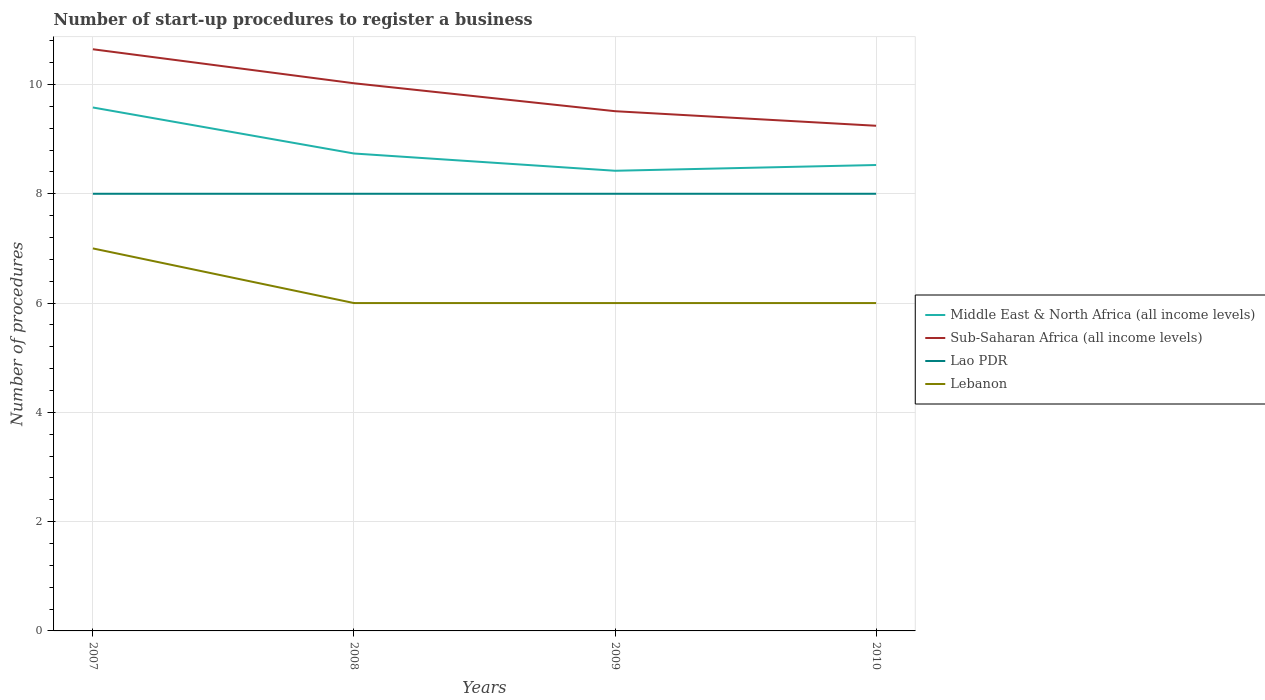How many different coloured lines are there?
Your answer should be compact. 4. Across all years, what is the maximum number of procedures required to register a business in Middle East & North Africa (all income levels)?
Your response must be concise. 8.42. What is the total number of procedures required to register a business in Middle East & North Africa (all income levels) in the graph?
Provide a short and direct response. 1.16. What is the difference between the highest and the second highest number of procedures required to register a business in Middle East & North Africa (all income levels)?
Keep it short and to the point. 1.16. What is the difference between two consecutive major ticks on the Y-axis?
Offer a terse response. 2. Does the graph contain grids?
Make the answer very short. Yes. Where does the legend appear in the graph?
Keep it short and to the point. Center right. What is the title of the graph?
Offer a very short reply. Number of start-up procedures to register a business. Does "Spain" appear as one of the legend labels in the graph?
Provide a succinct answer. No. What is the label or title of the Y-axis?
Offer a terse response. Number of procedures. What is the Number of procedures in Middle East & North Africa (all income levels) in 2007?
Provide a short and direct response. 9.58. What is the Number of procedures of Sub-Saharan Africa (all income levels) in 2007?
Your answer should be very brief. 10.64. What is the Number of procedures in Lebanon in 2007?
Make the answer very short. 7. What is the Number of procedures of Middle East & North Africa (all income levels) in 2008?
Provide a succinct answer. 8.74. What is the Number of procedures in Sub-Saharan Africa (all income levels) in 2008?
Make the answer very short. 10.02. What is the Number of procedures of Lao PDR in 2008?
Offer a terse response. 8. What is the Number of procedures in Lebanon in 2008?
Keep it short and to the point. 6. What is the Number of procedures of Middle East & North Africa (all income levels) in 2009?
Give a very brief answer. 8.42. What is the Number of procedures of Sub-Saharan Africa (all income levels) in 2009?
Provide a short and direct response. 9.51. What is the Number of procedures of Lao PDR in 2009?
Keep it short and to the point. 8. What is the Number of procedures in Middle East & North Africa (all income levels) in 2010?
Your answer should be compact. 8.53. What is the Number of procedures in Sub-Saharan Africa (all income levels) in 2010?
Make the answer very short. 9.24. Across all years, what is the maximum Number of procedures in Middle East & North Africa (all income levels)?
Your response must be concise. 9.58. Across all years, what is the maximum Number of procedures in Sub-Saharan Africa (all income levels)?
Provide a short and direct response. 10.64. Across all years, what is the maximum Number of procedures of Lao PDR?
Your answer should be very brief. 8. Across all years, what is the maximum Number of procedures in Lebanon?
Your answer should be very brief. 7. Across all years, what is the minimum Number of procedures of Middle East & North Africa (all income levels)?
Ensure brevity in your answer.  8.42. Across all years, what is the minimum Number of procedures in Sub-Saharan Africa (all income levels)?
Provide a short and direct response. 9.24. Across all years, what is the minimum Number of procedures of Lao PDR?
Provide a succinct answer. 8. What is the total Number of procedures in Middle East & North Africa (all income levels) in the graph?
Ensure brevity in your answer.  35.26. What is the total Number of procedures in Sub-Saharan Africa (all income levels) in the graph?
Provide a short and direct response. 39.42. What is the total Number of procedures of Lao PDR in the graph?
Provide a short and direct response. 32. What is the difference between the Number of procedures in Middle East & North Africa (all income levels) in 2007 and that in 2008?
Keep it short and to the point. 0.84. What is the difference between the Number of procedures of Sub-Saharan Africa (all income levels) in 2007 and that in 2008?
Give a very brief answer. 0.62. What is the difference between the Number of procedures of Lao PDR in 2007 and that in 2008?
Provide a short and direct response. 0. What is the difference between the Number of procedures of Middle East & North Africa (all income levels) in 2007 and that in 2009?
Your response must be concise. 1.16. What is the difference between the Number of procedures in Sub-Saharan Africa (all income levels) in 2007 and that in 2009?
Offer a very short reply. 1.13. What is the difference between the Number of procedures in Lao PDR in 2007 and that in 2009?
Provide a succinct answer. 0. What is the difference between the Number of procedures of Middle East & North Africa (all income levels) in 2007 and that in 2010?
Your answer should be very brief. 1.05. What is the difference between the Number of procedures in Lao PDR in 2007 and that in 2010?
Ensure brevity in your answer.  0. What is the difference between the Number of procedures in Middle East & North Africa (all income levels) in 2008 and that in 2009?
Provide a succinct answer. 0.32. What is the difference between the Number of procedures of Sub-Saharan Africa (all income levels) in 2008 and that in 2009?
Your response must be concise. 0.51. What is the difference between the Number of procedures in Middle East & North Africa (all income levels) in 2008 and that in 2010?
Offer a terse response. 0.21. What is the difference between the Number of procedures in Sub-Saharan Africa (all income levels) in 2008 and that in 2010?
Your response must be concise. 0.78. What is the difference between the Number of procedures in Lebanon in 2008 and that in 2010?
Ensure brevity in your answer.  0. What is the difference between the Number of procedures in Middle East & North Africa (all income levels) in 2009 and that in 2010?
Your answer should be compact. -0.11. What is the difference between the Number of procedures in Sub-Saharan Africa (all income levels) in 2009 and that in 2010?
Your answer should be very brief. 0.27. What is the difference between the Number of procedures of Lebanon in 2009 and that in 2010?
Provide a succinct answer. 0. What is the difference between the Number of procedures of Middle East & North Africa (all income levels) in 2007 and the Number of procedures of Sub-Saharan Africa (all income levels) in 2008?
Your answer should be very brief. -0.44. What is the difference between the Number of procedures of Middle East & North Africa (all income levels) in 2007 and the Number of procedures of Lao PDR in 2008?
Your answer should be compact. 1.58. What is the difference between the Number of procedures of Middle East & North Africa (all income levels) in 2007 and the Number of procedures of Lebanon in 2008?
Your response must be concise. 3.58. What is the difference between the Number of procedures in Sub-Saharan Africa (all income levels) in 2007 and the Number of procedures in Lao PDR in 2008?
Your answer should be compact. 2.64. What is the difference between the Number of procedures in Sub-Saharan Africa (all income levels) in 2007 and the Number of procedures in Lebanon in 2008?
Provide a succinct answer. 4.64. What is the difference between the Number of procedures in Middle East & North Africa (all income levels) in 2007 and the Number of procedures in Sub-Saharan Africa (all income levels) in 2009?
Provide a short and direct response. 0.07. What is the difference between the Number of procedures of Middle East & North Africa (all income levels) in 2007 and the Number of procedures of Lao PDR in 2009?
Give a very brief answer. 1.58. What is the difference between the Number of procedures in Middle East & North Africa (all income levels) in 2007 and the Number of procedures in Lebanon in 2009?
Give a very brief answer. 3.58. What is the difference between the Number of procedures of Sub-Saharan Africa (all income levels) in 2007 and the Number of procedures of Lao PDR in 2009?
Your answer should be very brief. 2.64. What is the difference between the Number of procedures of Sub-Saharan Africa (all income levels) in 2007 and the Number of procedures of Lebanon in 2009?
Your answer should be very brief. 4.64. What is the difference between the Number of procedures of Lao PDR in 2007 and the Number of procedures of Lebanon in 2009?
Keep it short and to the point. 2. What is the difference between the Number of procedures in Middle East & North Africa (all income levels) in 2007 and the Number of procedures in Sub-Saharan Africa (all income levels) in 2010?
Ensure brevity in your answer.  0.33. What is the difference between the Number of procedures of Middle East & North Africa (all income levels) in 2007 and the Number of procedures of Lao PDR in 2010?
Give a very brief answer. 1.58. What is the difference between the Number of procedures in Middle East & North Africa (all income levels) in 2007 and the Number of procedures in Lebanon in 2010?
Your response must be concise. 3.58. What is the difference between the Number of procedures in Sub-Saharan Africa (all income levels) in 2007 and the Number of procedures in Lao PDR in 2010?
Your answer should be compact. 2.64. What is the difference between the Number of procedures in Sub-Saharan Africa (all income levels) in 2007 and the Number of procedures in Lebanon in 2010?
Offer a very short reply. 4.64. What is the difference between the Number of procedures in Middle East & North Africa (all income levels) in 2008 and the Number of procedures in Sub-Saharan Africa (all income levels) in 2009?
Make the answer very short. -0.77. What is the difference between the Number of procedures of Middle East & North Africa (all income levels) in 2008 and the Number of procedures of Lao PDR in 2009?
Provide a succinct answer. 0.74. What is the difference between the Number of procedures in Middle East & North Africa (all income levels) in 2008 and the Number of procedures in Lebanon in 2009?
Provide a succinct answer. 2.74. What is the difference between the Number of procedures in Sub-Saharan Africa (all income levels) in 2008 and the Number of procedures in Lao PDR in 2009?
Keep it short and to the point. 2.02. What is the difference between the Number of procedures of Sub-Saharan Africa (all income levels) in 2008 and the Number of procedures of Lebanon in 2009?
Your answer should be compact. 4.02. What is the difference between the Number of procedures of Lao PDR in 2008 and the Number of procedures of Lebanon in 2009?
Provide a short and direct response. 2. What is the difference between the Number of procedures in Middle East & North Africa (all income levels) in 2008 and the Number of procedures in Sub-Saharan Africa (all income levels) in 2010?
Provide a short and direct response. -0.51. What is the difference between the Number of procedures in Middle East & North Africa (all income levels) in 2008 and the Number of procedures in Lao PDR in 2010?
Give a very brief answer. 0.74. What is the difference between the Number of procedures in Middle East & North Africa (all income levels) in 2008 and the Number of procedures in Lebanon in 2010?
Your response must be concise. 2.74. What is the difference between the Number of procedures in Sub-Saharan Africa (all income levels) in 2008 and the Number of procedures in Lao PDR in 2010?
Your response must be concise. 2.02. What is the difference between the Number of procedures of Sub-Saharan Africa (all income levels) in 2008 and the Number of procedures of Lebanon in 2010?
Provide a succinct answer. 4.02. What is the difference between the Number of procedures in Lao PDR in 2008 and the Number of procedures in Lebanon in 2010?
Keep it short and to the point. 2. What is the difference between the Number of procedures of Middle East & North Africa (all income levels) in 2009 and the Number of procedures of Sub-Saharan Africa (all income levels) in 2010?
Provide a short and direct response. -0.82. What is the difference between the Number of procedures in Middle East & North Africa (all income levels) in 2009 and the Number of procedures in Lao PDR in 2010?
Give a very brief answer. 0.42. What is the difference between the Number of procedures in Middle East & North Africa (all income levels) in 2009 and the Number of procedures in Lebanon in 2010?
Provide a succinct answer. 2.42. What is the difference between the Number of procedures in Sub-Saharan Africa (all income levels) in 2009 and the Number of procedures in Lao PDR in 2010?
Provide a short and direct response. 1.51. What is the difference between the Number of procedures of Sub-Saharan Africa (all income levels) in 2009 and the Number of procedures of Lebanon in 2010?
Your answer should be compact. 3.51. What is the difference between the Number of procedures of Lao PDR in 2009 and the Number of procedures of Lebanon in 2010?
Provide a succinct answer. 2. What is the average Number of procedures in Middle East & North Africa (all income levels) per year?
Your answer should be very brief. 8.82. What is the average Number of procedures in Sub-Saharan Africa (all income levels) per year?
Provide a succinct answer. 9.86. What is the average Number of procedures in Lebanon per year?
Offer a terse response. 6.25. In the year 2007, what is the difference between the Number of procedures of Middle East & North Africa (all income levels) and Number of procedures of Sub-Saharan Africa (all income levels)?
Your response must be concise. -1.07. In the year 2007, what is the difference between the Number of procedures of Middle East & North Africa (all income levels) and Number of procedures of Lao PDR?
Your response must be concise. 1.58. In the year 2007, what is the difference between the Number of procedures in Middle East & North Africa (all income levels) and Number of procedures in Lebanon?
Your answer should be compact. 2.58. In the year 2007, what is the difference between the Number of procedures in Sub-Saharan Africa (all income levels) and Number of procedures in Lao PDR?
Your answer should be compact. 2.64. In the year 2007, what is the difference between the Number of procedures in Sub-Saharan Africa (all income levels) and Number of procedures in Lebanon?
Provide a short and direct response. 3.64. In the year 2007, what is the difference between the Number of procedures in Lao PDR and Number of procedures in Lebanon?
Your response must be concise. 1. In the year 2008, what is the difference between the Number of procedures in Middle East & North Africa (all income levels) and Number of procedures in Sub-Saharan Africa (all income levels)?
Give a very brief answer. -1.29. In the year 2008, what is the difference between the Number of procedures in Middle East & North Africa (all income levels) and Number of procedures in Lao PDR?
Provide a succinct answer. 0.74. In the year 2008, what is the difference between the Number of procedures in Middle East & North Africa (all income levels) and Number of procedures in Lebanon?
Keep it short and to the point. 2.74. In the year 2008, what is the difference between the Number of procedures of Sub-Saharan Africa (all income levels) and Number of procedures of Lao PDR?
Provide a short and direct response. 2.02. In the year 2008, what is the difference between the Number of procedures of Sub-Saharan Africa (all income levels) and Number of procedures of Lebanon?
Provide a short and direct response. 4.02. In the year 2009, what is the difference between the Number of procedures of Middle East & North Africa (all income levels) and Number of procedures of Sub-Saharan Africa (all income levels)?
Keep it short and to the point. -1.09. In the year 2009, what is the difference between the Number of procedures of Middle East & North Africa (all income levels) and Number of procedures of Lao PDR?
Offer a terse response. 0.42. In the year 2009, what is the difference between the Number of procedures in Middle East & North Africa (all income levels) and Number of procedures in Lebanon?
Ensure brevity in your answer.  2.42. In the year 2009, what is the difference between the Number of procedures in Sub-Saharan Africa (all income levels) and Number of procedures in Lao PDR?
Offer a very short reply. 1.51. In the year 2009, what is the difference between the Number of procedures in Sub-Saharan Africa (all income levels) and Number of procedures in Lebanon?
Give a very brief answer. 3.51. In the year 2009, what is the difference between the Number of procedures of Lao PDR and Number of procedures of Lebanon?
Give a very brief answer. 2. In the year 2010, what is the difference between the Number of procedures in Middle East & North Africa (all income levels) and Number of procedures in Sub-Saharan Africa (all income levels)?
Make the answer very short. -0.72. In the year 2010, what is the difference between the Number of procedures of Middle East & North Africa (all income levels) and Number of procedures of Lao PDR?
Your answer should be very brief. 0.53. In the year 2010, what is the difference between the Number of procedures of Middle East & North Africa (all income levels) and Number of procedures of Lebanon?
Your answer should be very brief. 2.53. In the year 2010, what is the difference between the Number of procedures of Sub-Saharan Africa (all income levels) and Number of procedures of Lao PDR?
Your answer should be compact. 1.24. In the year 2010, what is the difference between the Number of procedures in Sub-Saharan Africa (all income levels) and Number of procedures in Lebanon?
Your response must be concise. 3.24. What is the ratio of the Number of procedures of Middle East & North Africa (all income levels) in 2007 to that in 2008?
Give a very brief answer. 1.1. What is the ratio of the Number of procedures in Sub-Saharan Africa (all income levels) in 2007 to that in 2008?
Make the answer very short. 1.06. What is the ratio of the Number of procedures in Lao PDR in 2007 to that in 2008?
Keep it short and to the point. 1. What is the ratio of the Number of procedures in Lebanon in 2007 to that in 2008?
Provide a short and direct response. 1.17. What is the ratio of the Number of procedures of Middle East & North Africa (all income levels) in 2007 to that in 2009?
Offer a very short reply. 1.14. What is the ratio of the Number of procedures in Sub-Saharan Africa (all income levels) in 2007 to that in 2009?
Your answer should be very brief. 1.12. What is the ratio of the Number of procedures of Lebanon in 2007 to that in 2009?
Ensure brevity in your answer.  1.17. What is the ratio of the Number of procedures of Middle East & North Africa (all income levels) in 2007 to that in 2010?
Your answer should be very brief. 1.12. What is the ratio of the Number of procedures of Sub-Saharan Africa (all income levels) in 2007 to that in 2010?
Give a very brief answer. 1.15. What is the ratio of the Number of procedures in Lao PDR in 2007 to that in 2010?
Your answer should be very brief. 1. What is the ratio of the Number of procedures of Middle East & North Africa (all income levels) in 2008 to that in 2009?
Give a very brief answer. 1.04. What is the ratio of the Number of procedures in Sub-Saharan Africa (all income levels) in 2008 to that in 2009?
Make the answer very short. 1.05. What is the ratio of the Number of procedures in Lebanon in 2008 to that in 2009?
Offer a very short reply. 1. What is the ratio of the Number of procedures in Middle East & North Africa (all income levels) in 2008 to that in 2010?
Offer a terse response. 1.02. What is the ratio of the Number of procedures in Sub-Saharan Africa (all income levels) in 2008 to that in 2010?
Your answer should be compact. 1.08. What is the ratio of the Number of procedures of Lao PDR in 2008 to that in 2010?
Offer a very short reply. 1. What is the ratio of the Number of procedures of Lebanon in 2008 to that in 2010?
Ensure brevity in your answer.  1. What is the ratio of the Number of procedures of Sub-Saharan Africa (all income levels) in 2009 to that in 2010?
Provide a short and direct response. 1.03. What is the ratio of the Number of procedures in Lao PDR in 2009 to that in 2010?
Ensure brevity in your answer.  1. What is the ratio of the Number of procedures in Lebanon in 2009 to that in 2010?
Offer a very short reply. 1. What is the difference between the highest and the second highest Number of procedures in Middle East & North Africa (all income levels)?
Make the answer very short. 0.84. What is the difference between the highest and the second highest Number of procedures of Sub-Saharan Africa (all income levels)?
Keep it short and to the point. 0.62. What is the difference between the highest and the second highest Number of procedures of Lebanon?
Ensure brevity in your answer.  1. What is the difference between the highest and the lowest Number of procedures of Middle East & North Africa (all income levels)?
Make the answer very short. 1.16. 